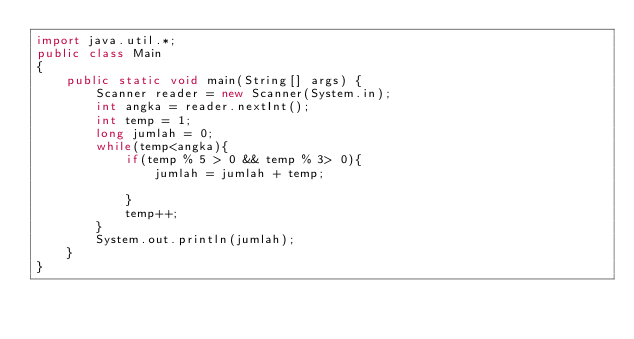Convert code to text. <code><loc_0><loc_0><loc_500><loc_500><_Java_>import java.util.*;
public class Main
{
    public static void main(String[] args) {
        Scanner reader = new Scanner(System.in);
        int angka = reader.nextInt();
        int temp = 1;
        long jumlah = 0;
        while(temp<angka){
            if(temp % 5 > 0 && temp % 3> 0){
                jumlah = jumlah + temp;
                
            }
            temp++;
        }
        System.out.println(jumlah);
    }
}
</code> 